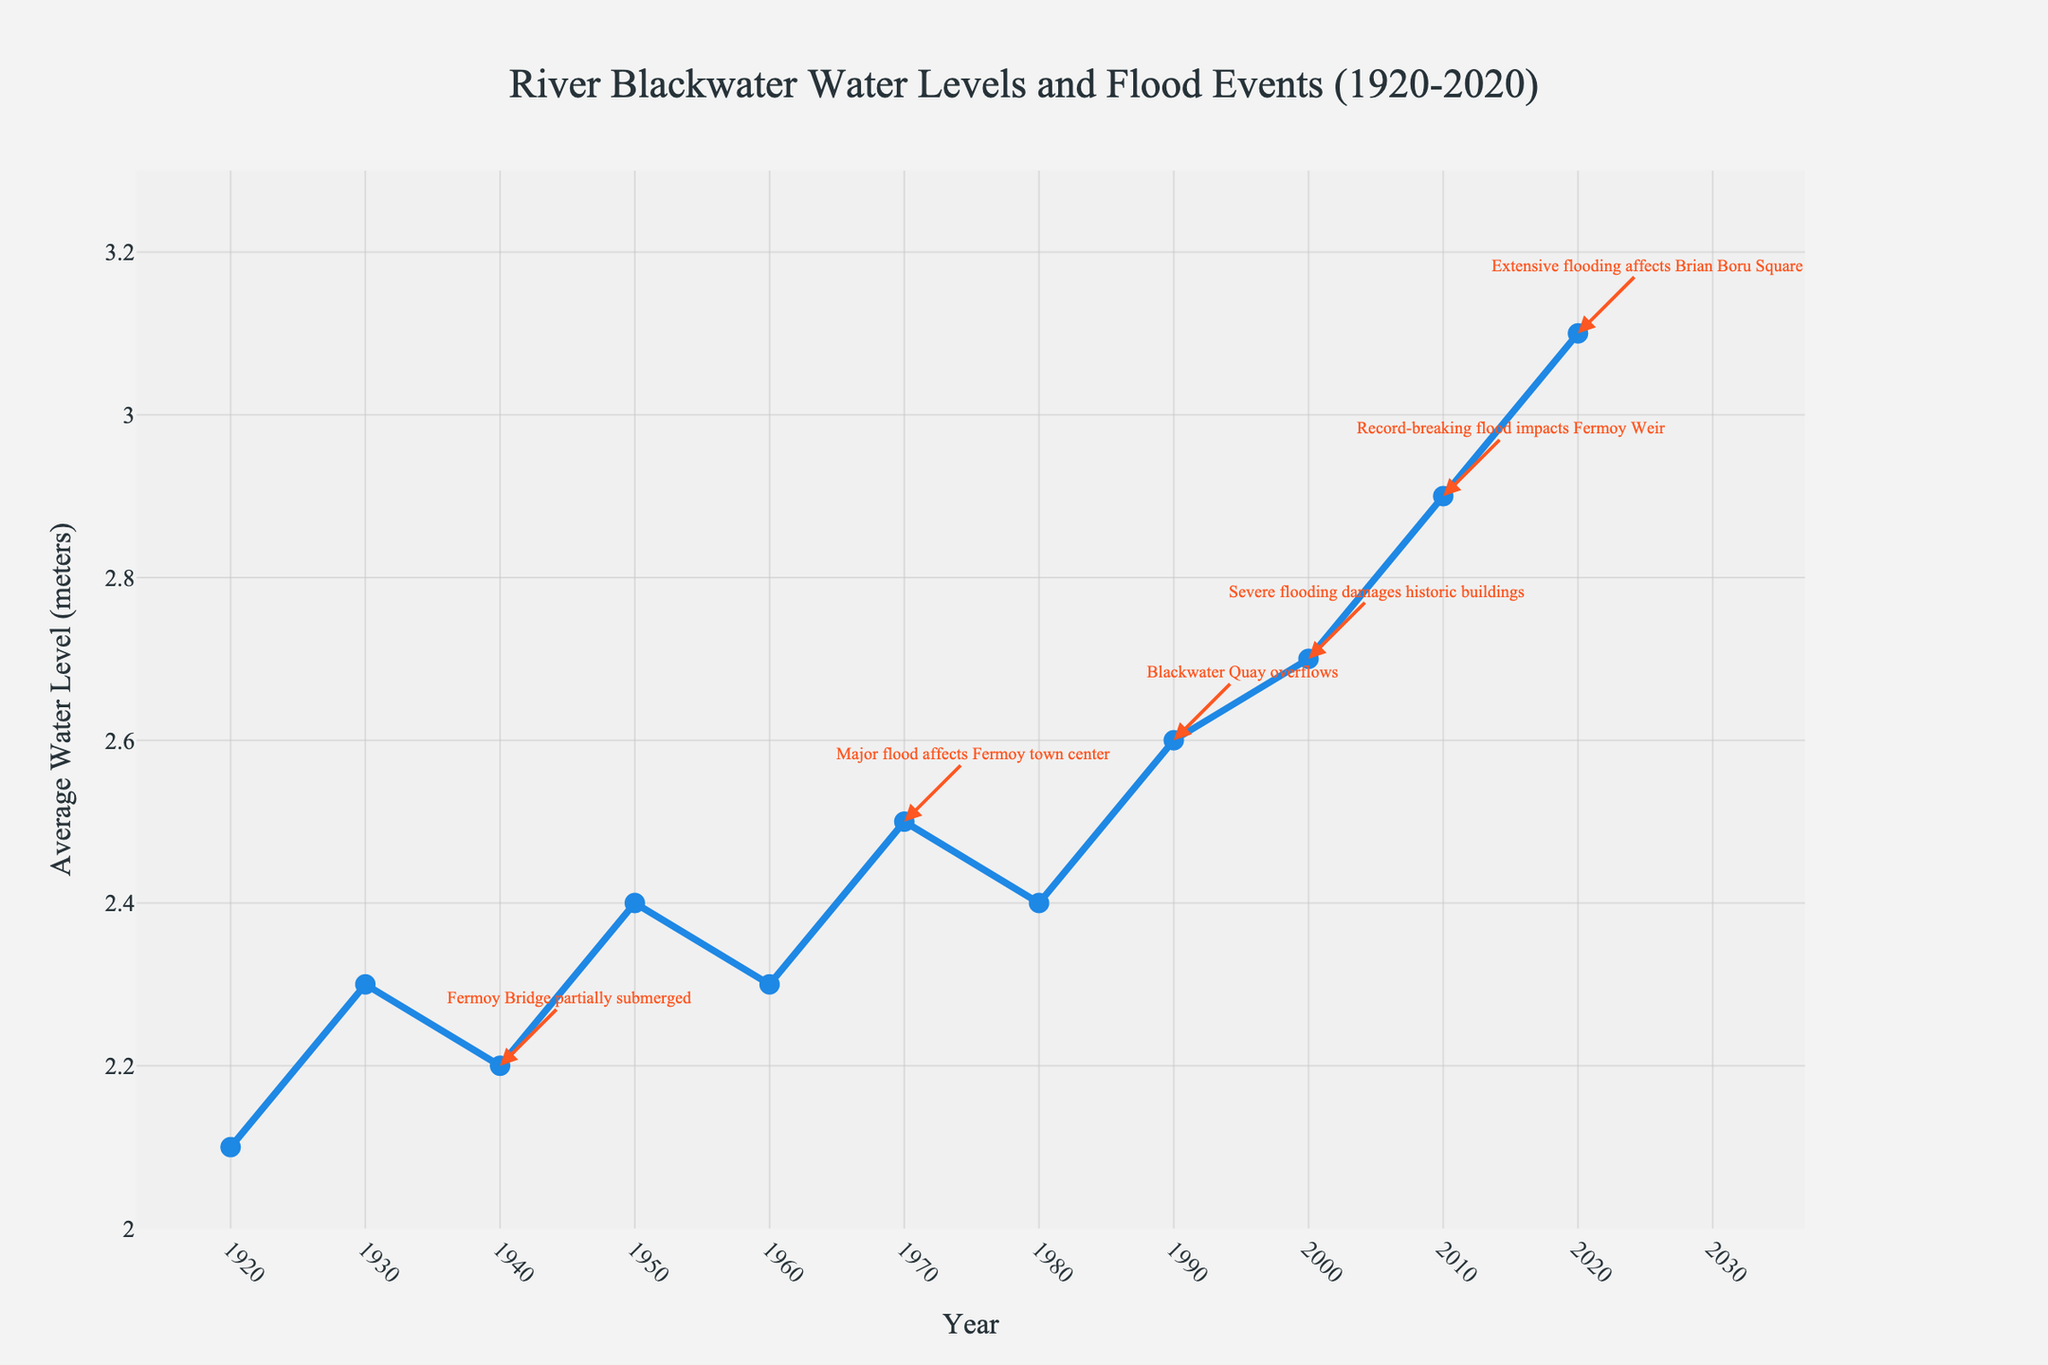What was the average water level in 1980? First, locate the year 1980 on the x-axis. Then, look at the corresponding point on the y-axis to find the average water level for that year.
Answer: 2.4 meters Which year had the highest recorded water level, and what was its value? Identify the year on the x-axis where the water level is at its highest point on the y-axis. The highest level appears around 2020.
Answer: 2020, 3.1 meters How many flood events are noted between 1920 and 2020? Count the number of annotations indicating notable flood events between the years 1920 and 2020. Each annotation represents a notable flood event.
Answer: 6 During which decade did the water level see the most significant increase? Calculate the difference in water levels between the start and end of each decade by examining the y-axis for each decade interval. The most significant increase is found by comparing these differences.
Answer: 2010s Compare the water levels of the years 1950 and 1990. Which year had higher water levels and by how much? Locate the years 1950 and 1990 on the x-axis, then compare their corresponding water levels on the y-axis. Subtract the water level of 1950 from that of 1990.
Answer: 1990 had higher levels by 0.2 meters What event happened in the year 1940, and what was the average water level that year? Identify the annotation for the year 1940 and read the event description. Look at the corresponding point on the y-axis for the average water level.
Answer: Fermoy Bridge partially submerged, 2.2 meters Between which two consecutive decades did the average water level increase the most? Calculate the difference in average water levels between the end of one decade and the start of the next, then find the pair with the largest difference.
Answer: 2000s to 2010s By how much did the average water level change from 1930 to 2020? Subtract the average water level in 1930 from that in 2020.
Answer: 0.8 meters What color are the annotations indicating flood events, and what might this imply? Identify the color of the arrows and text of the annotations on the chart, which are meant to indicate flood events.
Answer: Red, implying danger or warning What notable event occurred during the year with the record-breaking flood, and when was this? Find the annotation with the "record-breaking flood" description and identify the year and the event's details.
Answer: Impacts Fermoy Weir, 2010 